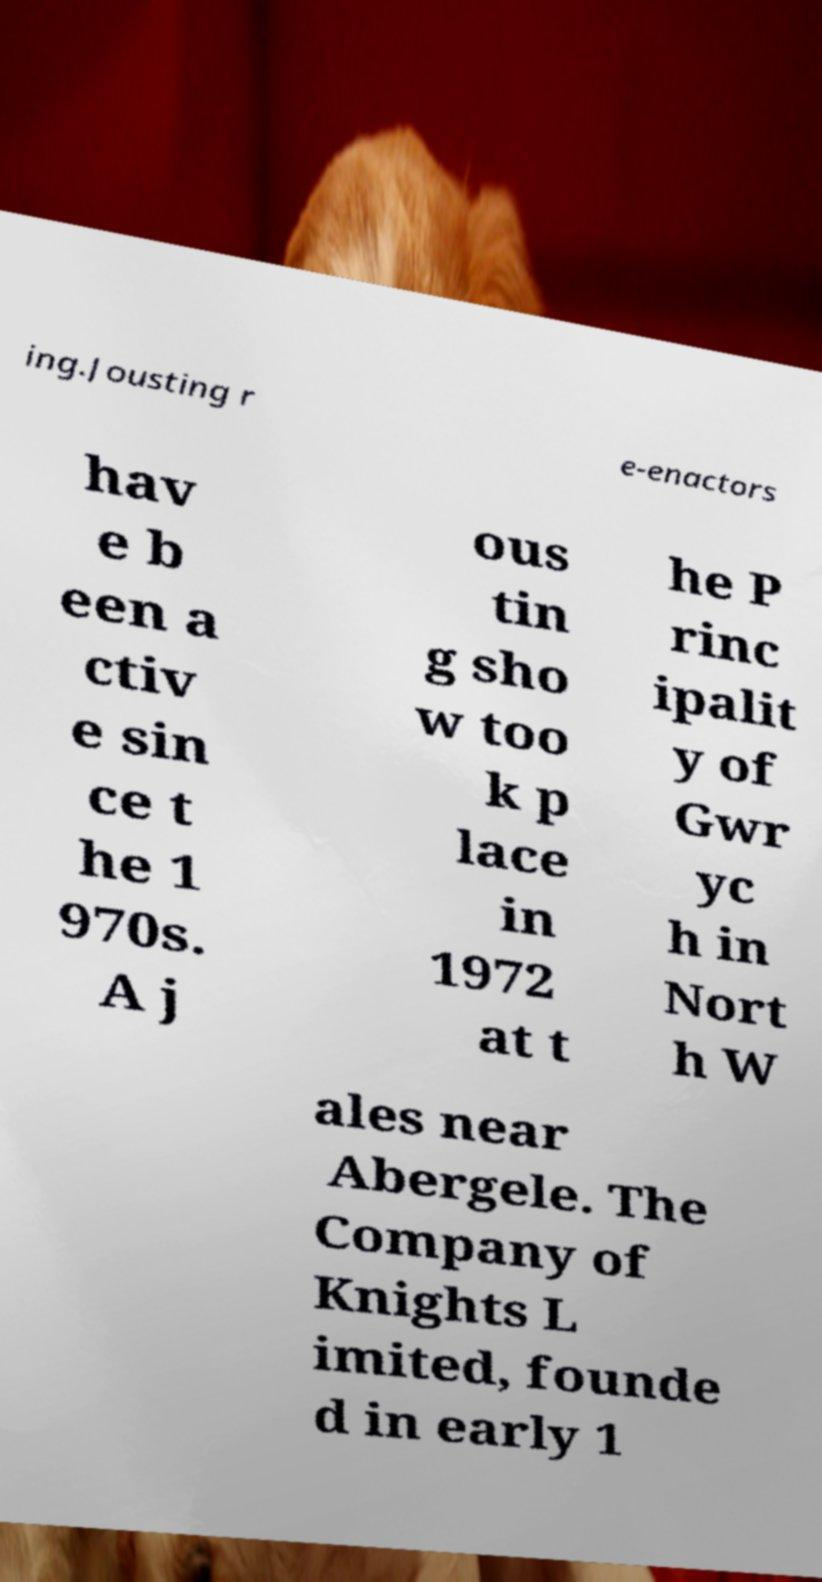Please identify and transcribe the text found in this image. ing.Jousting r e-enactors hav e b een a ctiv e sin ce t he 1 970s. A j ous tin g sho w too k p lace in 1972 at t he P rinc ipalit y of Gwr yc h in Nort h W ales near Abergele. The Company of Knights L imited, founde d in early 1 